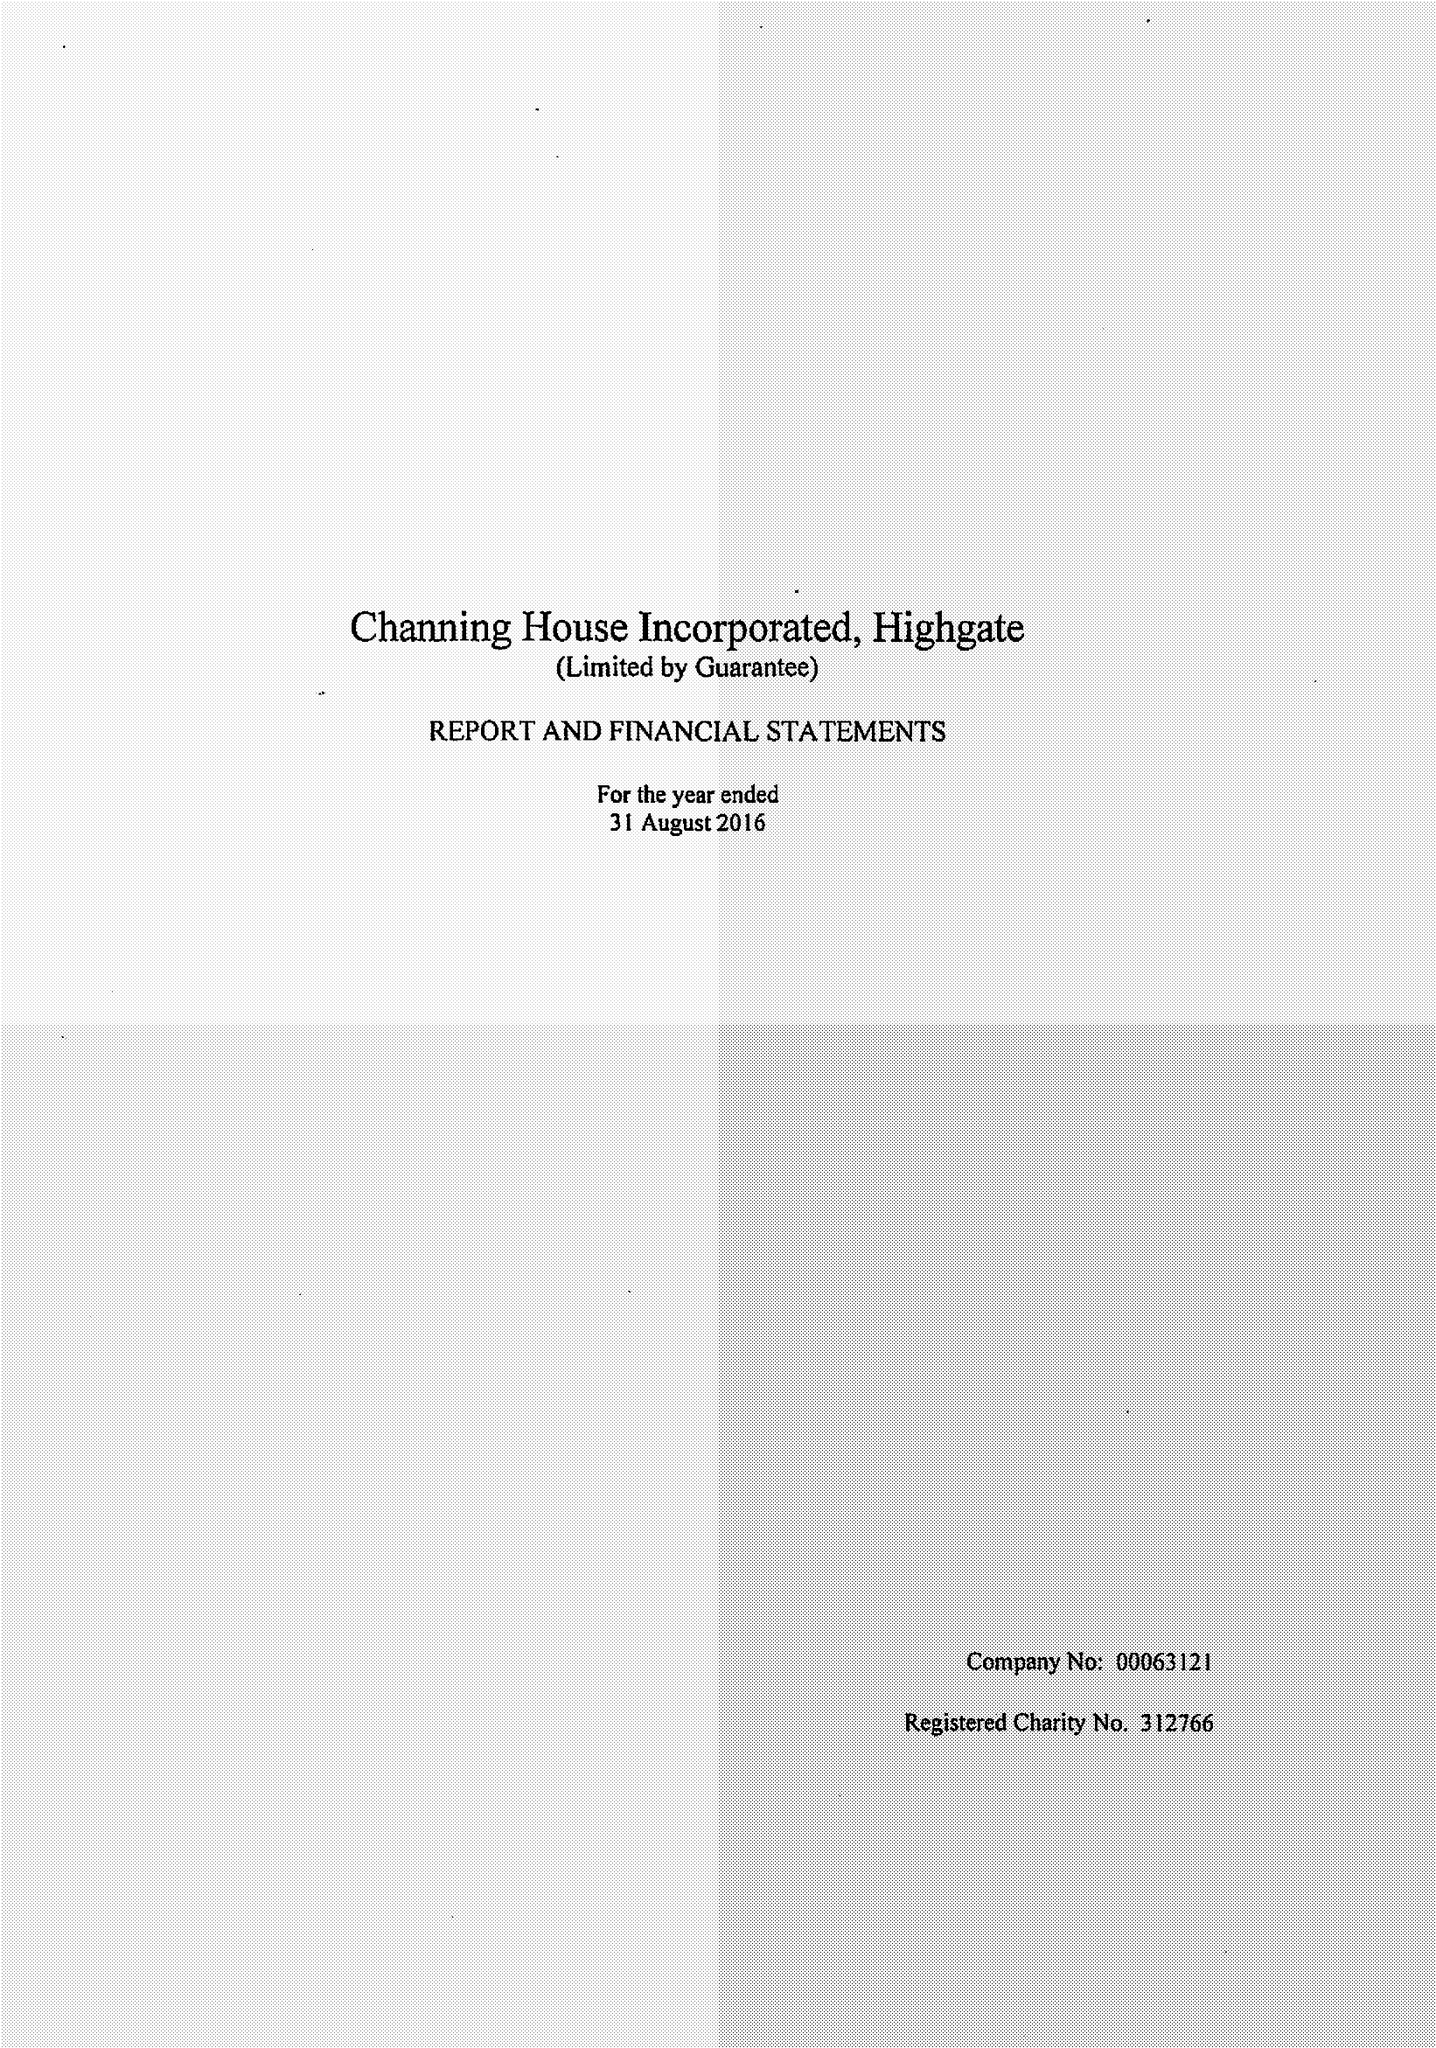What is the value for the address__post_town?
Answer the question using a single word or phrase. LONDON 